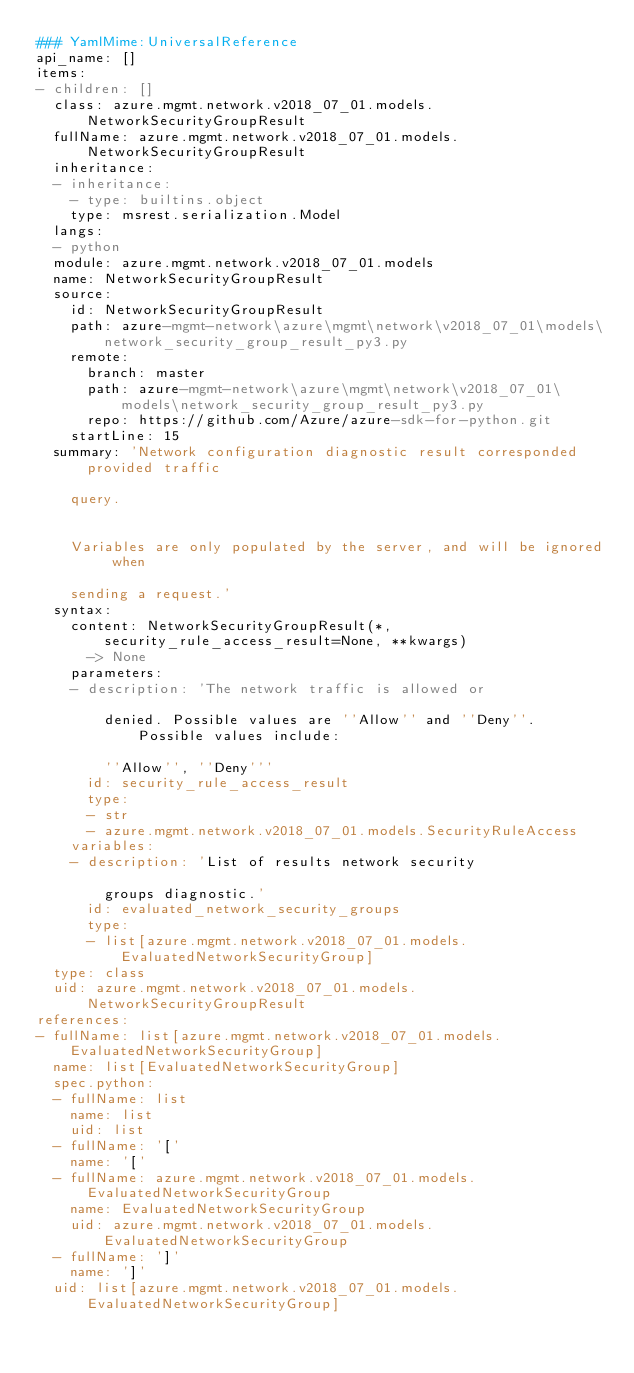<code> <loc_0><loc_0><loc_500><loc_500><_YAML_>### YamlMime:UniversalReference
api_name: []
items:
- children: []
  class: azure.mgmt.network.v2018_07_01.models.NetworkSecurityGroupResult
  fullName: azure.mgmt.network.v2018_07_01.models.NetworkSecurityGroupResult
  inheritance:
  - inheritance:
    - type: builtins.object
    type: msrest.serialization.Model
  langs:
  - python
  module: azure.mgmt.network.v2018_07_01.models
  name: NetworkSecurityGroupResult
  source:
    id: NetworkSecurityGroupResult
    path: azure-mgmt-network\azure\mgmt\network\v2018_07_01\models\network_security_group_result_py3.py
    remote:
      branch: master
      path: azure-mgmt-network\azure\mgmt\network\v2018_07_01\models\network_security_group_result_py3.py
      repo: https://github.com/Azure/azure-sdk-for-python.git
    startLine: 15
  summary: 'Network configuration diagnostic result corresponded provided traffic

    query.


    Variables are only populated by the server, and will be ignored when

    sending a request.'
  syntax:
    content: NetworkSecurityGroupResult(*, security_rule_access_result=None, **kwargs)
      -> None
    parameters:
    - description: 'The network traffic is allowed or

        denied. Possible values are ''Allow'' and ''Deny''. Possible values include:

        ''Allow'', ''Deny'''
      id: security_rule_access_result
      type:
      - str
      - azure.mgmt.network.v2018_07_01.models.SecurityRuleAccess
    variables:
    - description: 'List of results network security

        groups diagnostic.'
      id: evaluated_network_security_groups
      type:
      - list[azure.mgmt.network.v2018_07_01.models.EvaluatedNetworkSecurityGroup]
  type: class
  uid: azure.mgmt.network.v2018_07_01.models.NetworkSecurityGroupResult
references:
- fullName: list[azure.mgmt.network.v2018_07_01.models.EvaluatedNetworkSecurityGroup]
  name: list[EvaluatedNetworkSecurityGroup]
  spec.python:
  - fullName: list
    name: list
    uid: list
  - fullName: '['
    name: '['
  - fullName: azure.mgmt.network.v2018_07_01.models.EvaluatedNetworkSecurityGroup
    name: EvaluatedNetworkSecurityGroup
    uid: azure.mgmt.network.v2018_07_01.models.EvaluatedNetworkSecurityGroup
  - fullName: ']'
    name: ']'
  uid: list[azure.mgmt.network.v2018_07_01.models.EvaluatedNetworkSecurityGroup]
</code> 